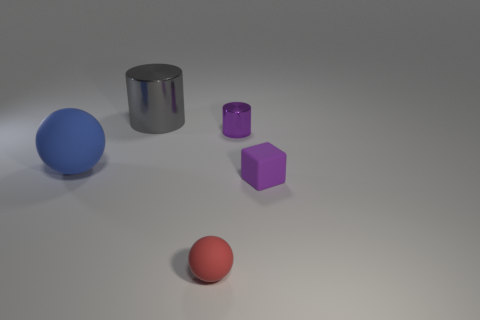Add 3 red matte balls. How many objects exist? 8 Subtract all blocks. How many objects are left? 4 Add 4 big red metal objects. How many big red metal objects exist? 4 Subtract 0 cyan balls. How many objects are left? 5 Subtract all tiny red things. Subtract all blocks. How many objects are left? 3 Add 4 large blue matte things. How many large blue matte things are left? 5 